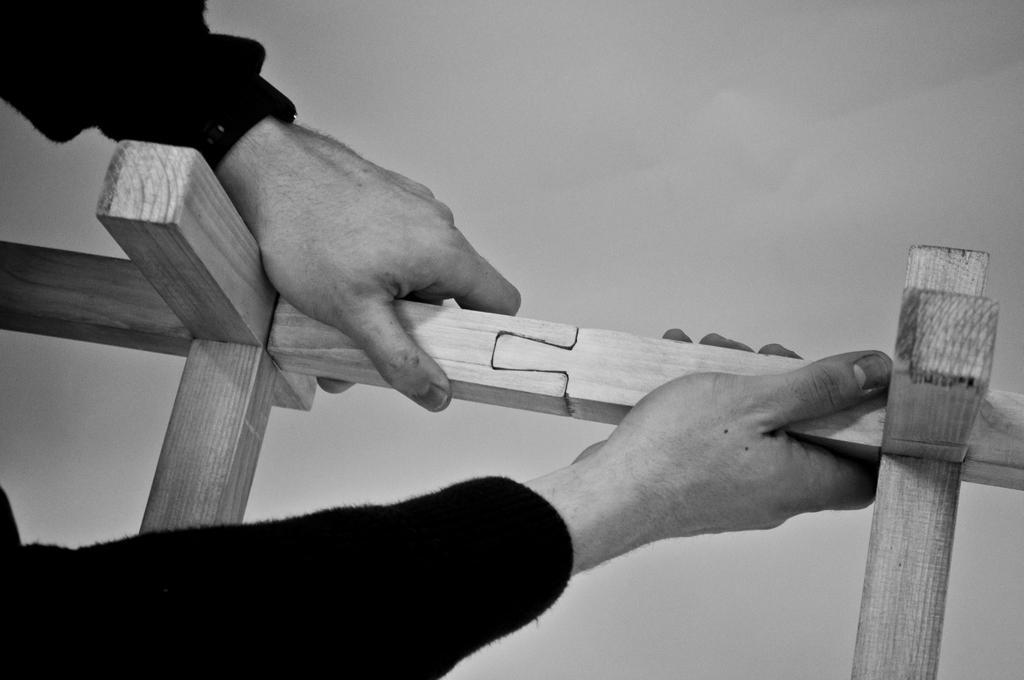Could you give a brief overview of what you see in this image? In this picture I can see human hands holding wood. 